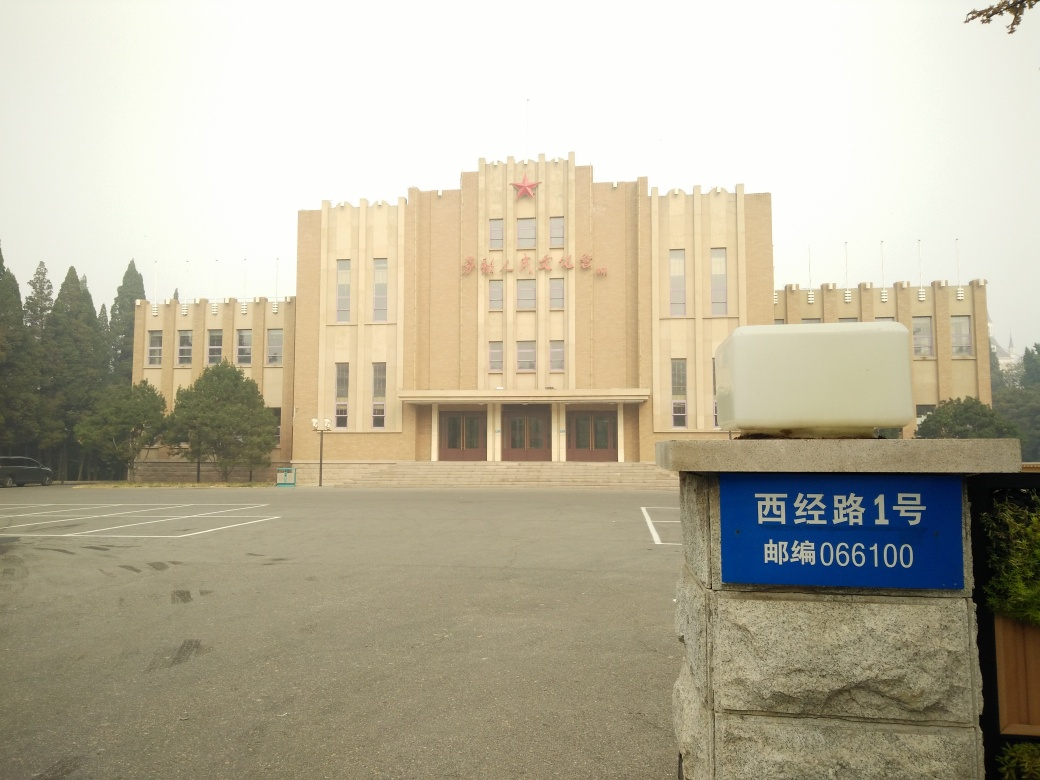Can you identify the style or period of the architecture of the building in the image? The building in the image features characteristics typical of Art Deco architecture, noted by its symmetrical, rectangular facade and the use of linear ornamental detailing. This architectural style was most popular in the 1920s and 1930s. What can we deduce about the weather and overall atmosphere from the image? The atmosphere appears hazy, possibly due to fog, mist, or air pollution, which obscures the clarity and color saturation in the image. This affects visibility and gives the image a somewhat somber or muted tone. 